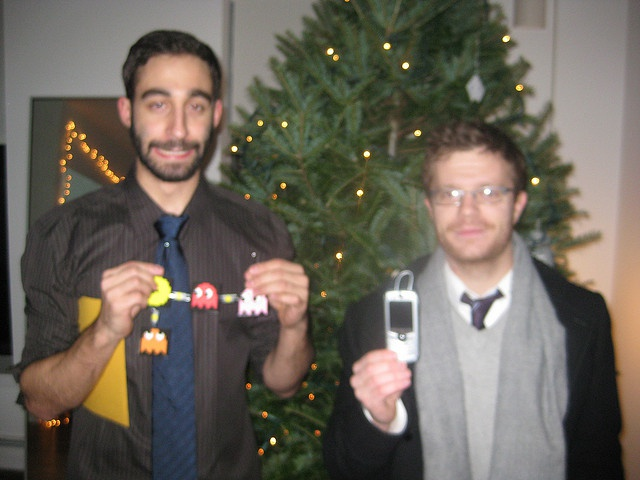Describe the objects in this image and their specific colors. I can see people in black, gray, and tan tones, people in black, darkgray, lightgray, and gray tones, tie in black, navy, darkblue, and gray tones, cell phone in black, white, gray, darkgray, and lightgray tones, and tie in black, gray, white, and darkgray tones in this image. 